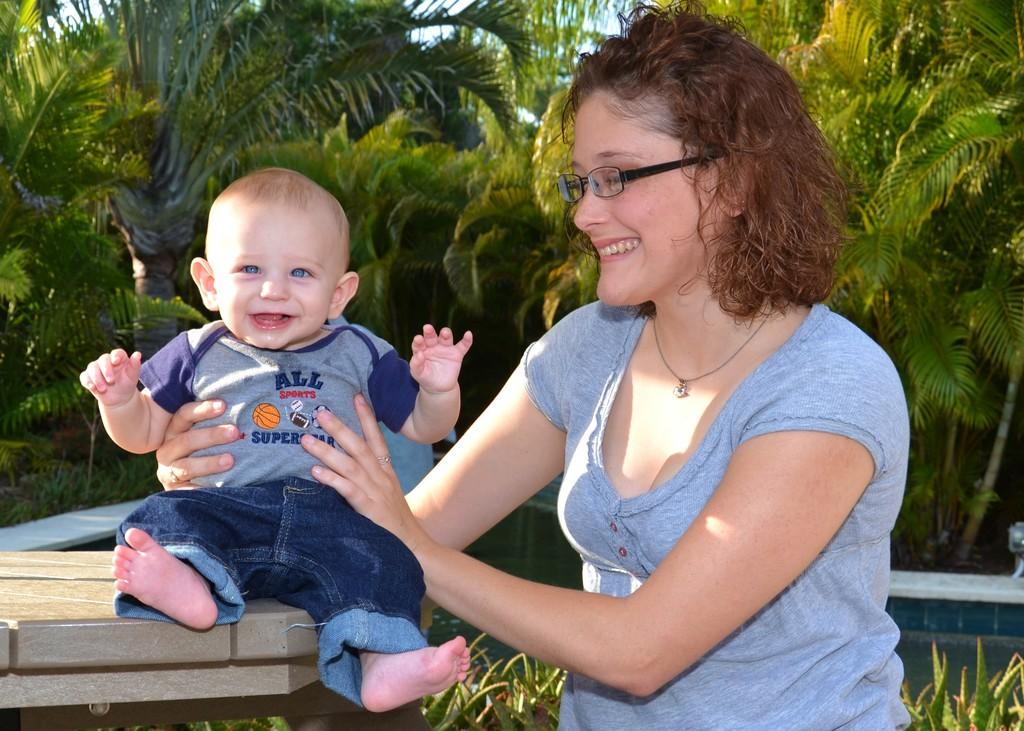How many people are visible in the image? There are two people in the front of the image. What is located in the front of the image along with the people? There is a table and plants in the front of the image. What can be seen in the background of the image? There are trees in the background of the image. What type of suit is the person in the image wearing? There is no person wearing a suit in the image. The image does not show any cars in the background? 